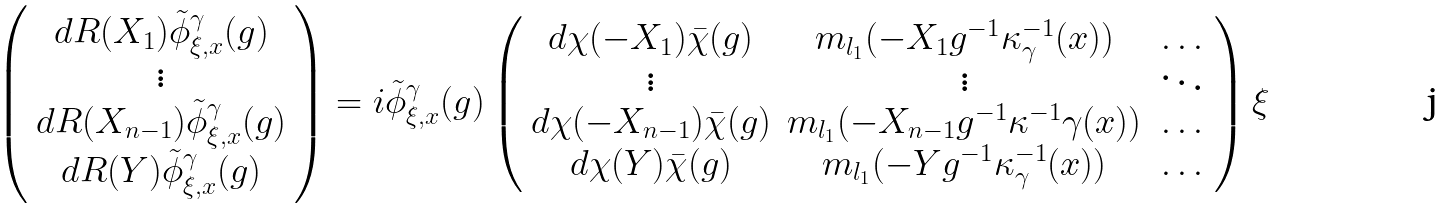<formula> <loc_0><loc_0><loc_500><loc_500>\left ( \begin{array} { c } d R ( X _ { 1 } ) \tilde { \phi } ^ { \gamma } _ { \xi , x } ( g ) \\ \vdots \\ d R ( X _ { n - 1 } ) \tilde { \phi } ^ { \gamma } _ { \xi , x } ( g ) \\ d R ( Y ) \tilde { \phi } _ { \xi , x } ^ { \gamma } ( g ) \end{array} \right ) = i \tilde { \phi } _ { \xi , x } ^ { \gamma } ( g ) \left ( \begin{array} { c c c } d \chi ( - X _ { 1 } ) \bar { \chi } ( g ) & m _ { l _ { 1 } } ( - X _ { 1 } g ^ { - 1 } \kappa ^ { - 1 } _ { \gamma } ( x ) ) & \dots \\ \vdots & \vdots & \ddots \\ d \chi ( - X _ { n - 1 } ) \bar { \chi } ( g ) & m _ { l _ { 1 } } ( - X _ { n - 1 } g ^ { - 1 } \kappa ^ { - 1 } \gamma ( x ) ) & \dots \\ d \chi ( Y ) \bar { \chi } ( g ) & m _ { l _ { 1 } } ( - Y g ^ { - 1 } \kappa ^ { - 1 } _ { \gamma } ( x ) ) & \dots \end{array} \right ) \xi</formula> 